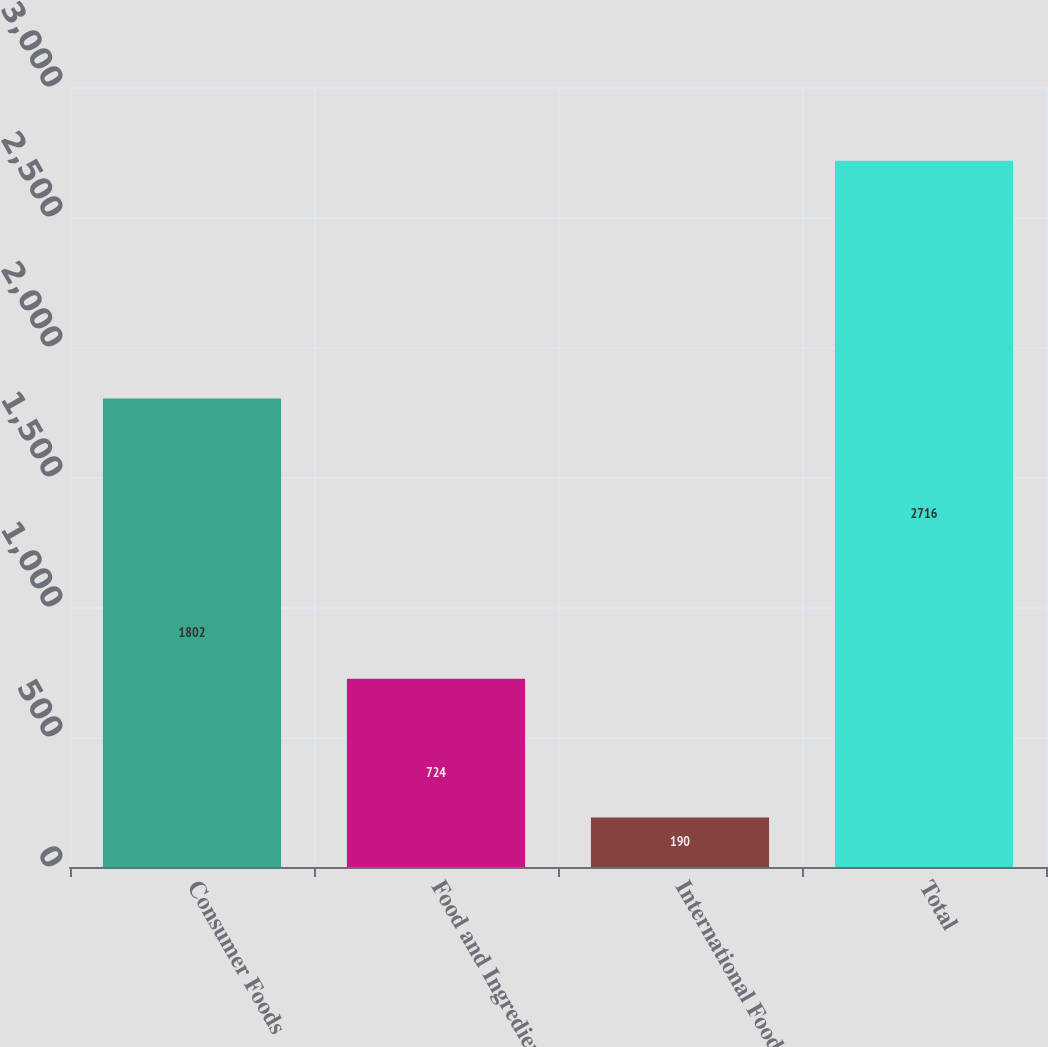Convert chart to OTSL. <chart><loc_0><loc_0><loc_500><loc_500><bar_chart><fcel>Consumer Foods<fcel>Food and Ingredients<fcel>International Foods<fcel>Total<nl><fcel>1802<fcel>724<fcel>190<fcel>2716<nl></chart> 